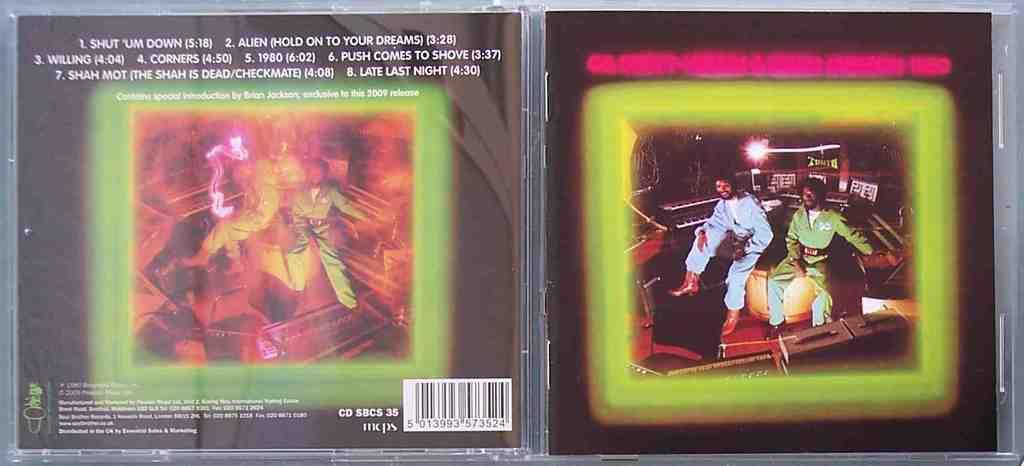What is the first song on this cd?
Your response must be concise. Shut um down. 